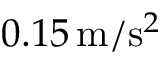<formula> <loc_0><loc_0><loc_500><loc_500>0 . 1 5 \, m / s ^ { 2 }</formula> 